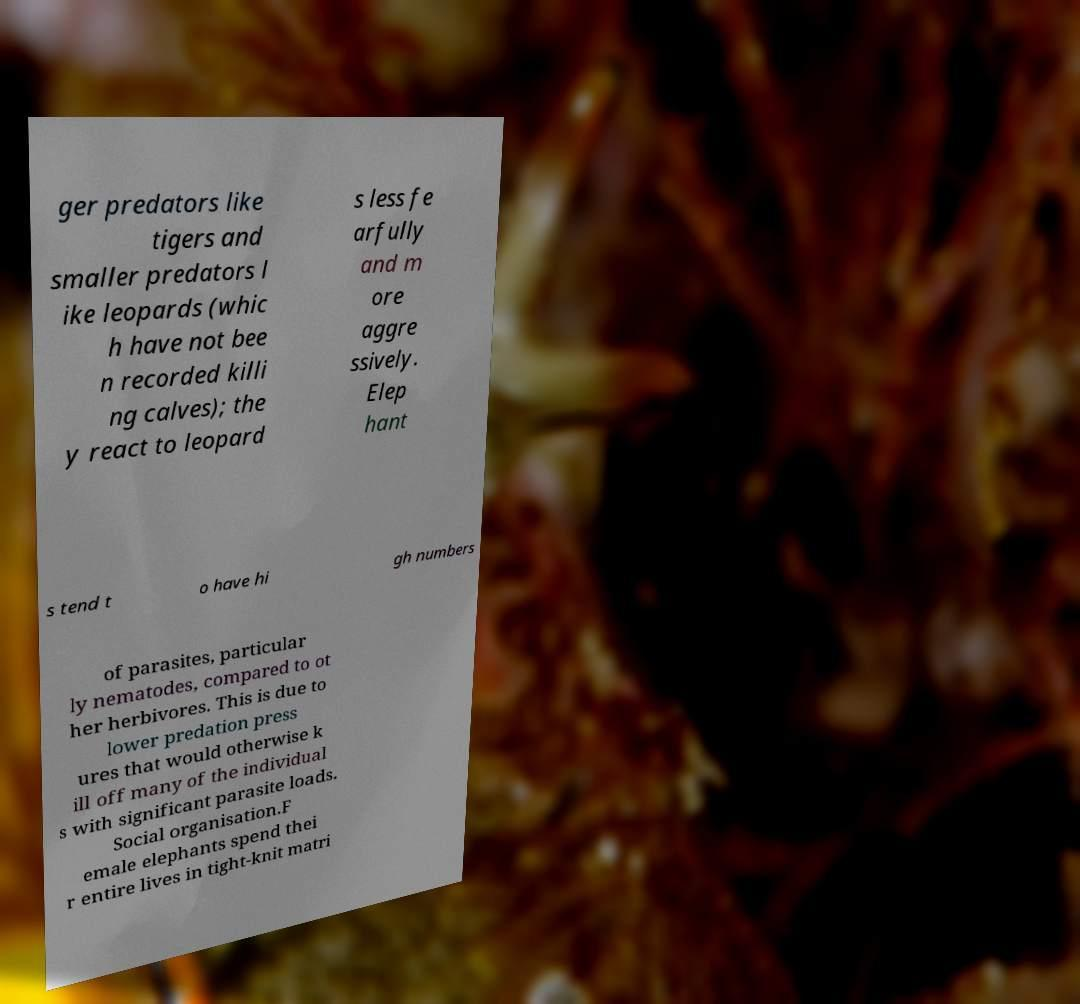Can you accurately transcribe the text from the provided image for me? ger predators like tigers and smaller predators l ike leopards (whic h have not bee n recorded killi ng calves); the y react to leopard s less fe arfully and m ore aggre ssively. Elep hant s tend t o have hi gh numbers of parasites, particular ly nematodes, compared to ot her herbivores. This is due to lower predation press ures that would otherwise k ill off many of the individual s with significant parasite loads. Social organisation.F emale elephants spend thei r entire lives in tight-knit matri 